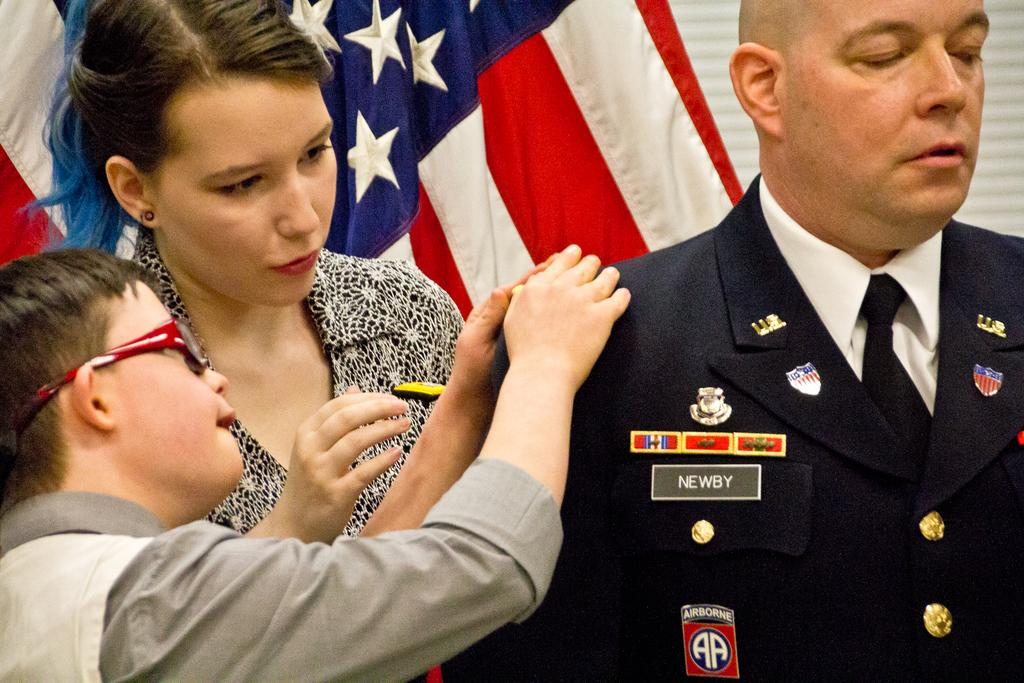How many individuals are present in the image? There are three people in the image. Can you describe the background of the image? There is a flag in the background of the image. What condition is the yam in, as seen in the image? There is no yam present in the image, so its condition cannot be determined. 